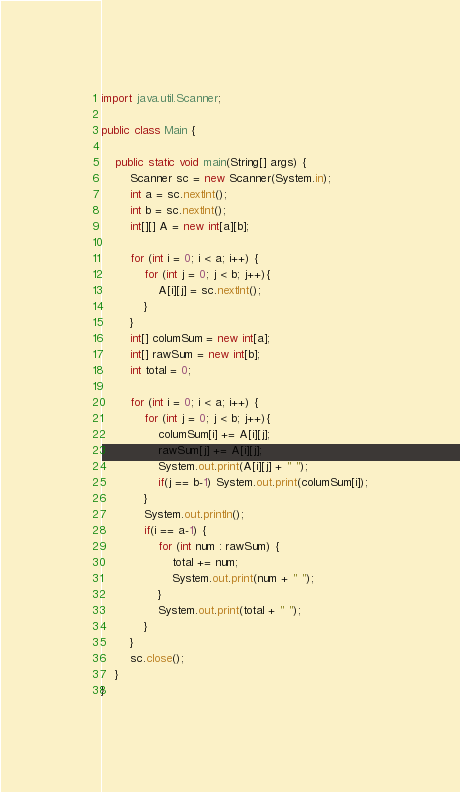Convert code to text. <code><loc_0><loc_0><loc_500><loc_500><_Java_>import java.util.Scanner;

public class Main {

	public static void main(String[] args) {
		Scanner sc = new Scanner(System.in);
		int a = sc.nextInt();
		int b = sc.nextInt();
		int[][] A = new int[a][b];

		for (int i = 0; i < a; i++) {
			for (int j = 0; j < b; j++){
				A[i][j] = sc.nextInt();
			}
		}
		int[] columSum = new int[a];
		int[] rawSum = new int[b];
		int total = 0;

		for (int i = 0; i < a; i++) {
			for (int j = 0; j < b; j++){
				columSum[i] += A[i][j];
				rawSum[j] += A[i][j];
				System.out.print(A[i][j] + " ");
				if(j == b-1) System.out.print(columSum[i]);
			}
			System.out.println();
			if(i == a-1) {
				for (int num : rawSum) {
					total += num;
					System.out.print(num + " ");
				}
				System.out.print(total + " ");
			}
		}
		sc.close();
	}
}</code> 